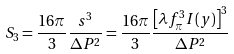<formula> <loc_0><loc_0><loc_500><loc_500>S _ { 3 } = \frac { 1 6 \pi } { 3 } \frac { s ^ { 3 } } { \Delta P ^ { 2 } } = \frac { 1 6 \pi } { 3 } \frac { \left [ \lambda f _ { \pi } ^ { 3 } I ( y ) \right ] ^ { 3 } } { \Delta P ^ { 2 } }</formula> 